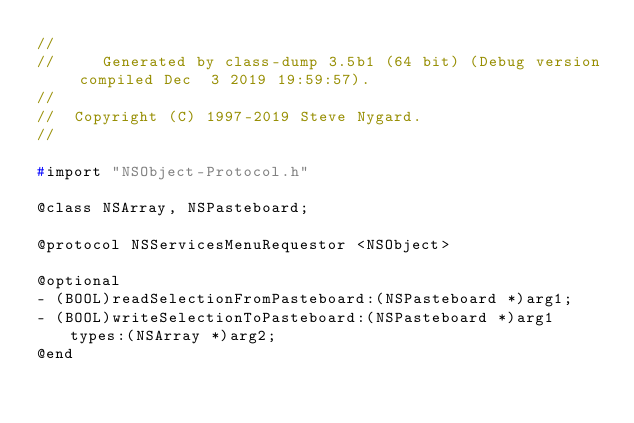Convert code to text. <code><loc_0><loc_0><loc_500><loc_500><_C_>//
//     Generated by class-dump 3.5b1 (64 bit) (Debug version compiled Dec  3 2019 19:59:57).
//
//  Copyright (C) 1997-2019 Steve Nygard.
//

#import "NSObject-Protocol.h"

@class NSArray, NSPasteboard;

@protocol NSServicesMenuRequestor <NSObject>

@optional
- (BOOL)readSelectionFromPasteboard:(NSPasteboard *)arg1;
- (BOOL)writeSelectionToPasteboard:(NSPasteboard *)arg1 types:(NSArray *)arg2;
@end

</code> 